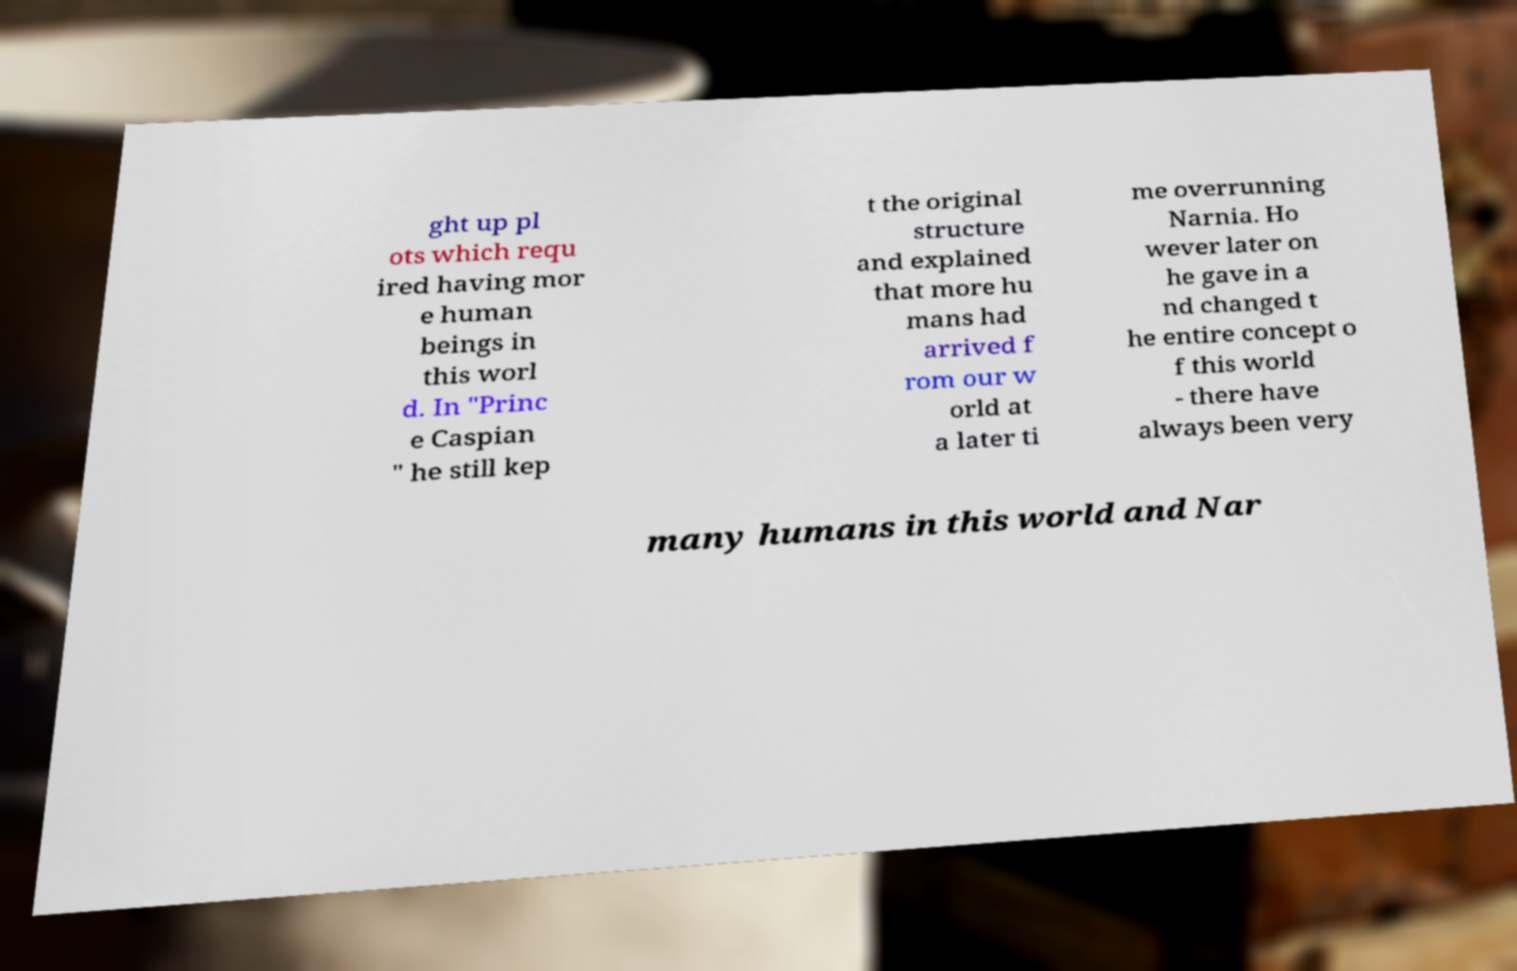There's text embedded in this image that I need extracted. Can you transcribe it verbatim? ght up pl ots which requ ired having mor e human beings in this worl d. In "Princ e Caspian " he still kep t the original structure and explained that more hu mans had arrived f rom our w orld at a later ti me overrunning Narnia. Ho wever later on he gave in a nd changed t he entire concept o f this world - there have always been very many humans in this world and Nar 